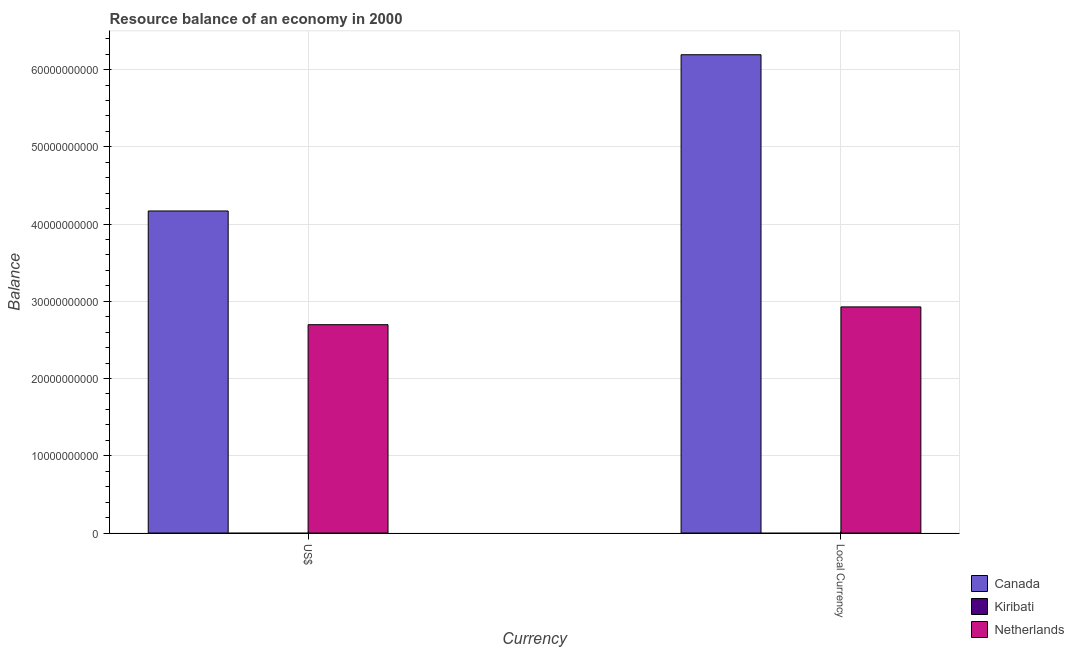How many different coloured bars are there?
Your answer should be very brief. 2. Are the number of bars per tick equal to the number of legend labels?
Ensure brevity in your answer.  No. Are the number of bars on each tick of the X-axis equal?
Offer a very short reply. Yes. How many bars are there on the 1st tick from the left?
Your answer should be very brief. 2. How many bars are there on the 2nd tick from the right?
Your answer should be very brief. 2. What is the label of the 1st group of bars from the left?
Provide a succinct answer. US$. What is the resource balance in us$ in Netherlands?
Make the answer very short. 2.70e+1. Across all countries, what is the maximum resource balance in us$?
Provide a succinct answer. 4.17e+1. Across all countries, what is the minimum resource balance in constant us$?
Provide a short and direct response. 0. In which country was the resource balance in constant us$ maximum?
Offer a terse response. Canada. What is the total resource balance in us$ in the graph?
Keep it short and to the point. 6.87e+1. What is the difference between the resource balance in constant us$ in Netherlands and that in Canada?
Your answer should be very brief. -3.26e+1. What is the difference between the resource balance in constant us$ in Netherlands and the resource balance in us$ in Kiribati?
Offer a very short reply. 2.93e+1. What is the average resource balance in constant us$ per country?
Give a very brief answer. 3.04e+1. What is the difference between the resource balance in us$ and resource balance in constant us$ in Netherlands?
Make the answer very short. -2.30e+09. What is the ratio of the resource balance in constant us$ in Netherlands to that in Canada?
Your answer should be very brief. 0.47. Is the resource balance in constant us$ in Netherlands less than that in Canada?
Offer a very short reply. Yes. In how many countries, is the resource balance in constant us$ greater than the average resource balance in constant us$ taken over all countries?
Ensure brevity in your answer.  1. How many bars are there?
Keep it short and to the point. 4. Are all the bars in the graph horizontal?
Your answer should be very brief. No. How many countries are there in the graph?
Your answer should be very brief. 3. What is the difference between two consecutive major ticks on the Y-axis?
Provide a succinct answer. 1.00e+1. Does the graph contain any zero values?
Keep it short and to the point. Yes. Where does the legend appear in the graph?
Make the answer very short. Bottom right. How many legend labels are there?
Offer a terse response. 3. What is the title of the graph?
Your answer should be very brief. Resource balance of an economy in 2000. Does "Kosovo" appear as one of the legend labels in the graph?
Your response must be concise. No. What is the label or title of the X-axis?
Give a very brief answer. Currency. What is the label or title of the Y-axis?
Give a very brief answer. Balance. What is the Balance of Canada in US$?
Your answer should be very brief. 4.17e+1. What is the Balance of Kiribati in US$?
Your answer should be compact. 0. What is the Balance in Netherlands in US$?
Your answer should be compact. 2.70e+1. What is the Balance in Canada in Local Currency?
Give a very brief answer. 6.19e+1. What is the Balance of Netherlands in Local Currency?
Ensure brevity in your answer.  2.93e+1. Across all Currency, what is the maximum Balance of Canada?
Your response must be concise. 6.19e+1. Across all Currency, what is the maximum Balance of Netherlands?
Your response must be concise. 2.93e+1. Across all Currency, what is the minimum Balance of Canada?
Provide a succinct answer. 4.17e+1. Across all Currency, what is the minimum Balance in Netherlands?
Make the answer very short. 2.70e+1. What is the total Balance in Canada in the graph?
Your answer should be compact. 1.04e+11. What is the total Balance in Netherlands in the graph?
Make the answer very short. 5.62e+1. What is the difference between the Balance of Canada in US$ and that in Local Currency?
Provide a short and direct response. -2.02e+1. What is the difference between the Balance of Netherlands in US$ and that in Local Currency?
Ensure brevity in your answer.  -2.30e+09. What is the difference between the Balance of Canada in US$ and the Balance of Netherlands in Local Currency?
Your answer should be very brief. 1.24e+1. What is the average Balance of Canada per Currency?
Provide a succinct answer. 5.18e+1. What is the average Balance of Kiribati per Currency?
Make the answer very short. 0. What is the average Balance in Netherlands per Currency?
Your response must be concise. 2.81e+1. What is the difference between the Balance in Canada and Balance in Netherlands in US$?
Keep it short and to the point. 1.47e+1. What is the difference between the Balance in Canada and Balance in Netherlands in Local Currency?
Your answer should be very brief. 3.26e+1. What is the ratio of the Balance in Canada in US$ to that in Local Currency?
Offer a very short reply. 0.67. What is the ratio of the Balance of Netherlands in US$ to that in Local Currency?
Ensure brevity in your answer.  0.92. What is the difference between the highest and the second highest Balance in Canada?
Offer a very short reply. 2.02e+1. What is the difference between the highest and the second highest Balance of Netherlands?
Provide a succinct answer. 2.30e+09. What is the difference between the highest and the lowest Balance of Canada?
Your answer should be very brief. 2.02e+1. What is the difference between the highest and the lowest Balance of Netherlands?
Make the answer very short. 2.30e+09. 